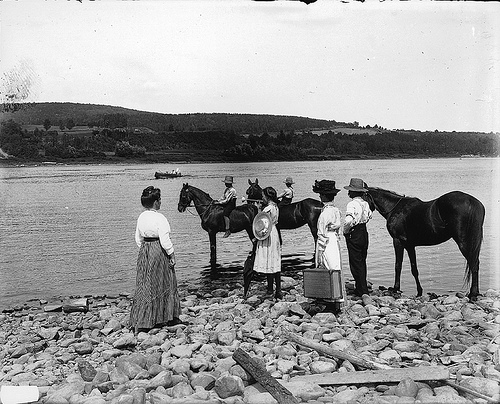<image>What event is this? It is ambiguous what event this is. It could be any number of things from a wild west event to a beach day, a social event, a wedding, or horseback riding. What event is this? I don't know what event this is. It could be any of 'wild west', 'water polo', 'beach day', 'waiting for boat', 'social', 'wedding', 'traveling', 'none', 'river crossing', or 'horseback riding'. 